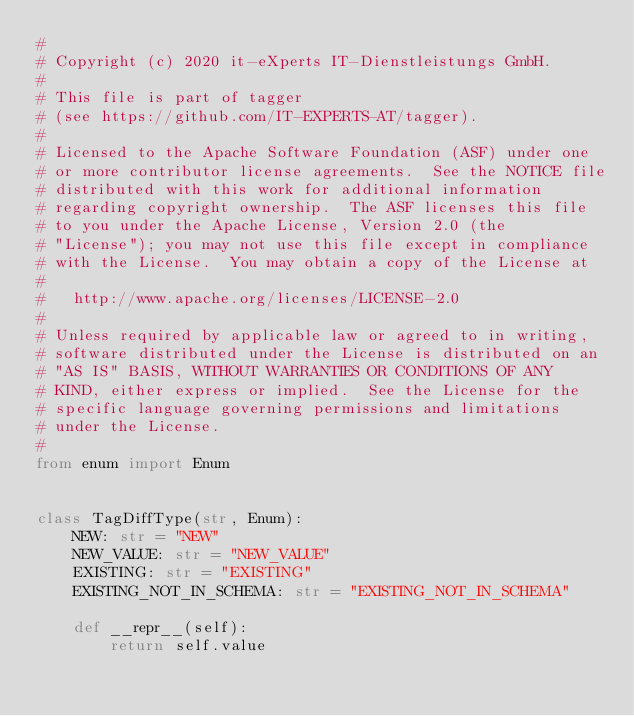Convert code to text. <code><loc_0><loc_0><loc_500><loc_500><_Python_>#
# Copyright (c) 2020 it-eXperts IT-Dienstleistungs GmbH.
#
# This file is part of tagger
# (see https://github.com/IT-EXPERTS-AT/tagger).
#
# Licensed to the Apache Software Foundation (ASF) under one
# or more contributor license agreements.  See the NOTICE file
# distributed with this work for additional information
# regarding copyright ownership.  The ASF licenses this file
# to you under the Apache License, Version 2.0 (the
# "License"); you may not use this file except in compliance
# with the License.  You may obtain a copy of the License at
#
#   http://www.apache.org/licenses/LICENSE-2.0
#
# Unless required by applicable law or agreed to in writing,
# software distributed under the License is distributed on an
# "AS IS" BASIS, WITHOUT WARRANTIES OR CONDITIONS OF ANY
# KIND, either express or implied.  See the License for the
# specific language governing permissions and limitations
# under the License.
#
from enum import Enum


class TagDiffType(str, Enum):
    NEW: str = "NEW"
    NEW_VALUE: str = "NEW_VALUE"
    EXISTING: str = "EXISTING"
    EXISTING_NOT_IN_SCHEMA: str = "EXISTING_NOT_IN_SCHEMA"

    def __repr__(self):
        return self.value
</code> 